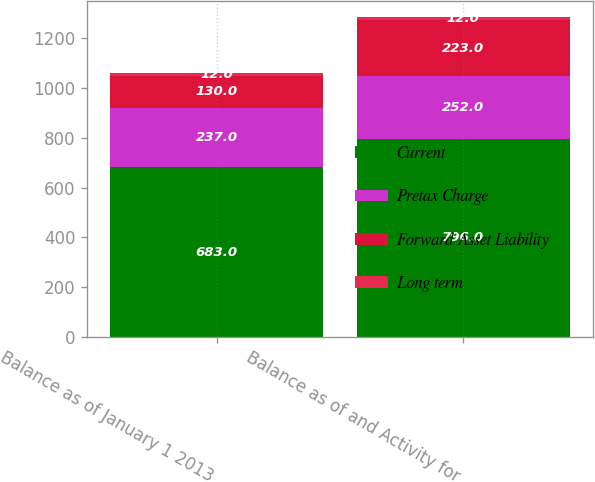Convert chart. <chart><loc_0><loc_0><loc_500><loc_500><stacked_bar_chart><ecel><fcel>Balance as of January 1 2013<fcel>Balance as of and Activity for<nl><fcel>Current<fcel>683<fcel>796<nl><fcel>Pretax Charge<fcel>237<fcel>252<nl><fcel>Forward Asset Liability<fcel>130<fcel>223<nl><fcel>Long term<fcel>12<fcel>12<nl></chart> 